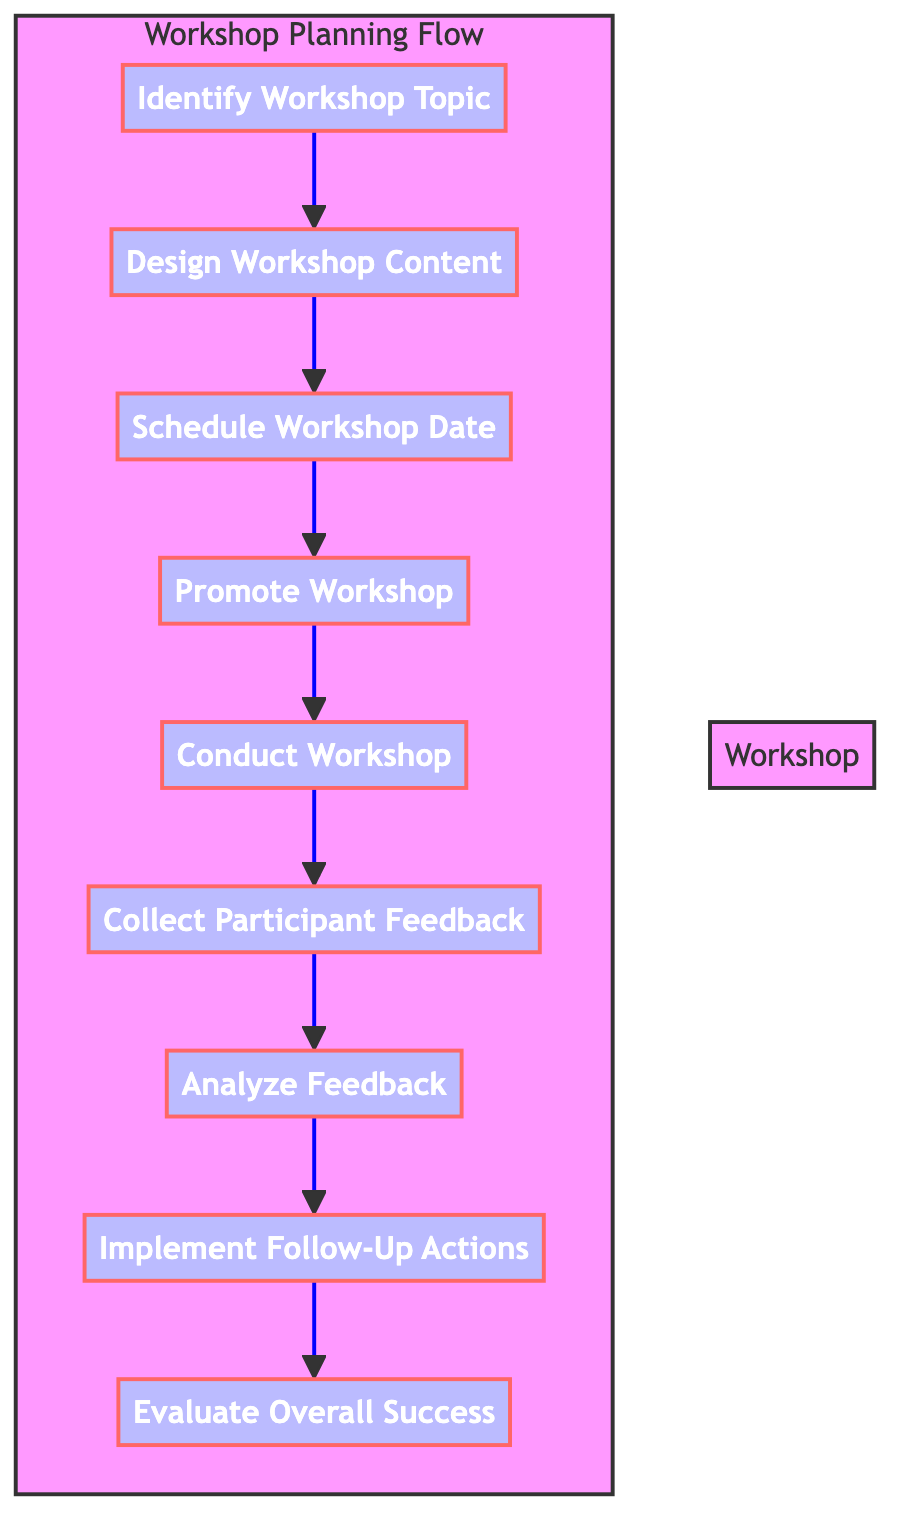What is the first step in the workshop planning flow? The first step in the flow is identified by the node labeled "Identify Workshop Topic," which is the starting point of the entire process.
Answer: Identify Workshop Topic What is the last step in the workshop planning flow? The last step is found at the bottom of the flow, indicated by the node "Evaluate Overall Success," representing the final action taken after all other steps have been completed.
Answer: Evaluate Overall Success How many steps are there in the workshop planning flow? By counting each individual step represented by the nodes in the diagram, there are a total of 9 distinct steps.
Answer: 9 Which step comes directly after "Conduct Workshop"? Looking at the flow direction, the step that immediately follows "Conduct Workshop" is "Collect Participant Feedback," as indicated by the arrow pointing from one step to the other.
Answer: Collect Participant Feedback Which two steps are preceded by "Analyze Feedback"? The steps "Collect Participant Feedback" and "Implement Follow-Up Actions" are both part of the flow that comes before and after "Analyze Feedback", respectively.
Answer: Collect Participant Feedback, Implement Follow-Up Actions What is the relationship between "Design Workshop Content" and "Promote Workshop"? In the flow diagram, "Design Workshop Content" directly leads to "Promote Workshop" as they are connected by an arrow indicating the progression in the workshop setup.
Answer: Design Workshop Content leads to Promote Workshop What action is taken to gather opinions on workshop effectiveness? The action described in the flow for gathering opinions on workshop effectiveness is "Collect Participant Feedback," which is explicitly mentioned as the process for obtaining input from participants.
Answer: Collect Participant Feedback What happens after analyzing feedback in the workshop planning process? Following the step of "Analyze Feedback," the next action in the flow is "Implement Follow-Up Actions," which indicates that adjustments will be made based on collected feedback results.
Answer: Implement Follow-Up Actions How many steps involve direct participant interaction? The steps where direct interaction with participants occurs include "Conduct Workshop" and "Collect Participant Feedback," totaling 2 steps in the process.
Answer: 2 